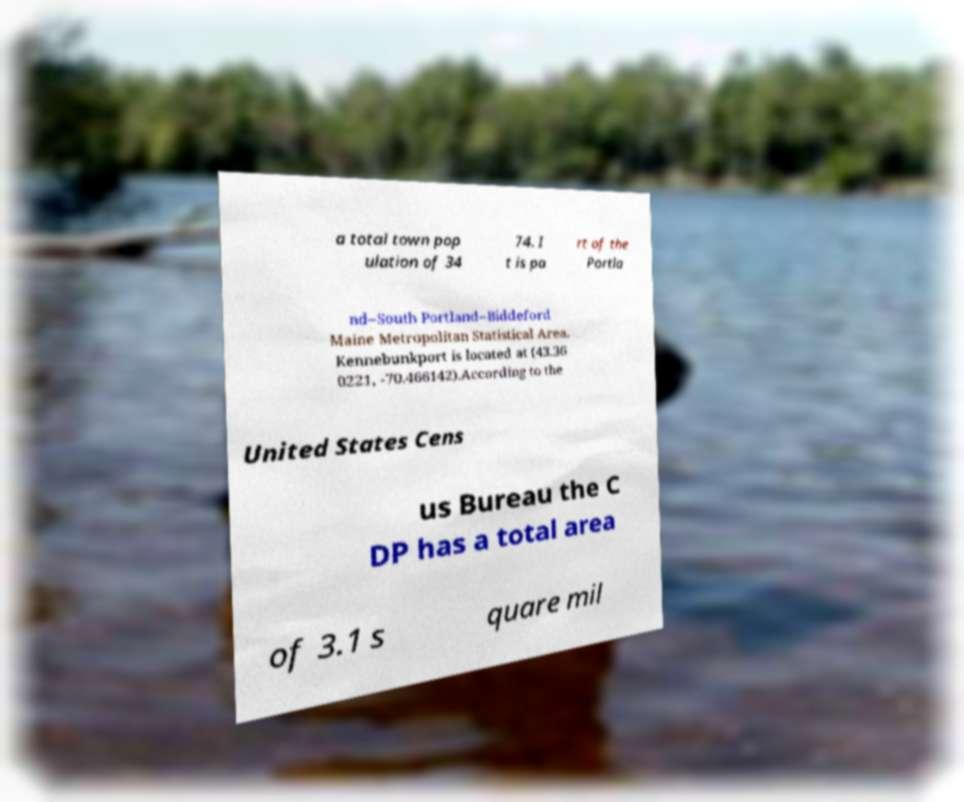Please identify and transcribe the text found in this image. a total town pop ulation of 34 74. I t is pa rt of the Portla nd–South Portland–Biddeford Maine Metropolitan Statistical Area. Kennebunkport is located at (43.36 0221, -70.466142).According to the United States Cens us Bureau the C DP has a total area of 3.1 s quare mil 